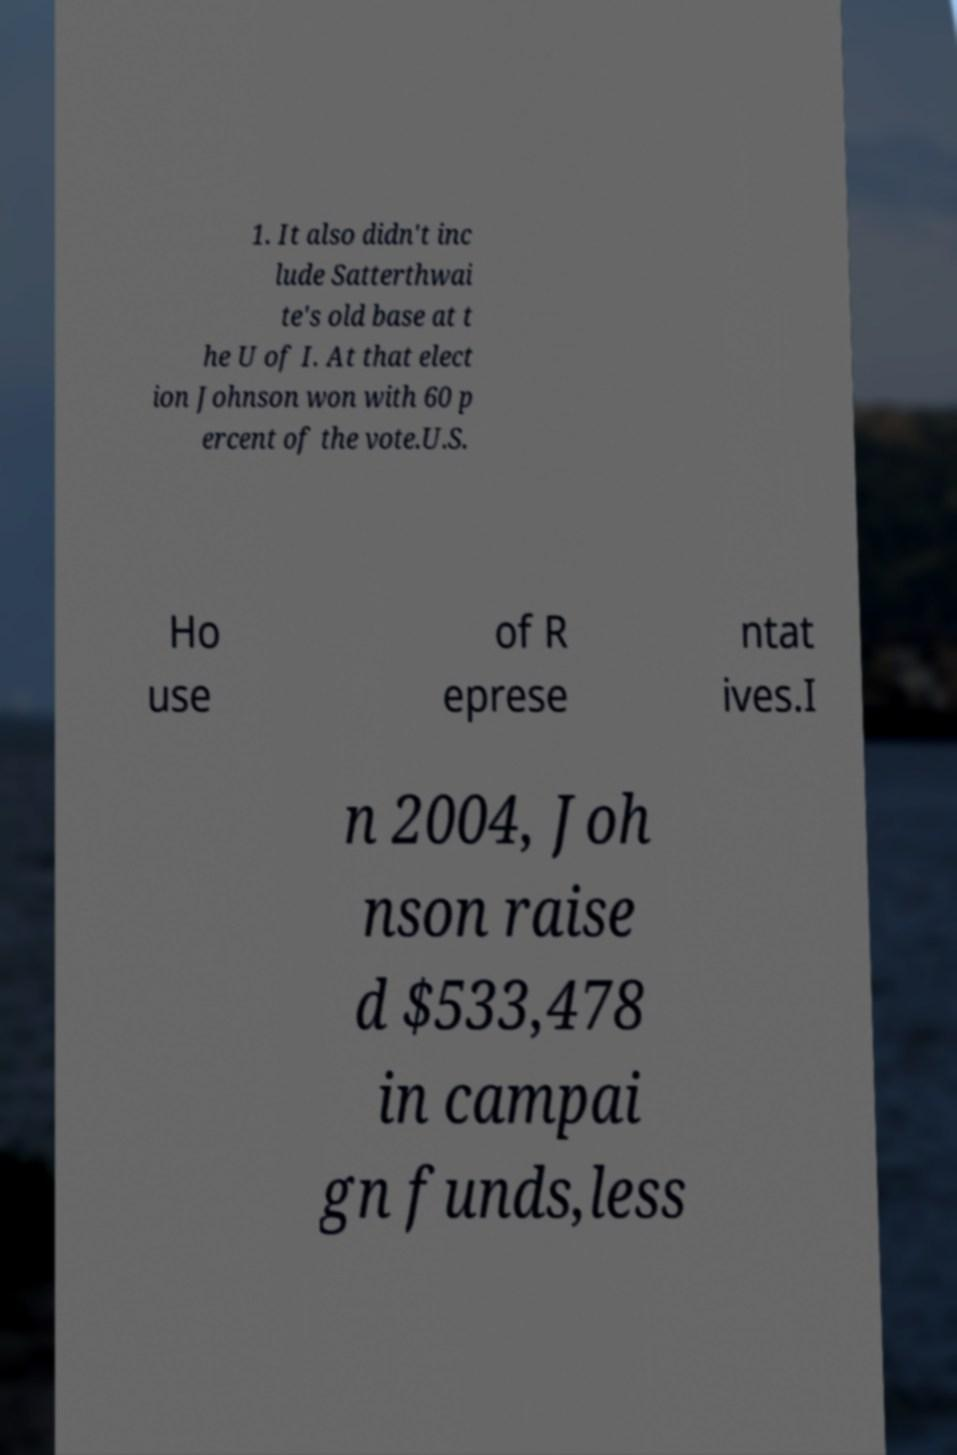Could you extract and type out the text from this image? 1. It also didn't inc lude Satterthwai te's old base at t he U of I. At that elect ion Johnson won with 60 p ercent of the vote.U.S. Ho use of R eprese ntat ives.I n 2004, Joh nson raise d $533,478 in campai gn funds,less 